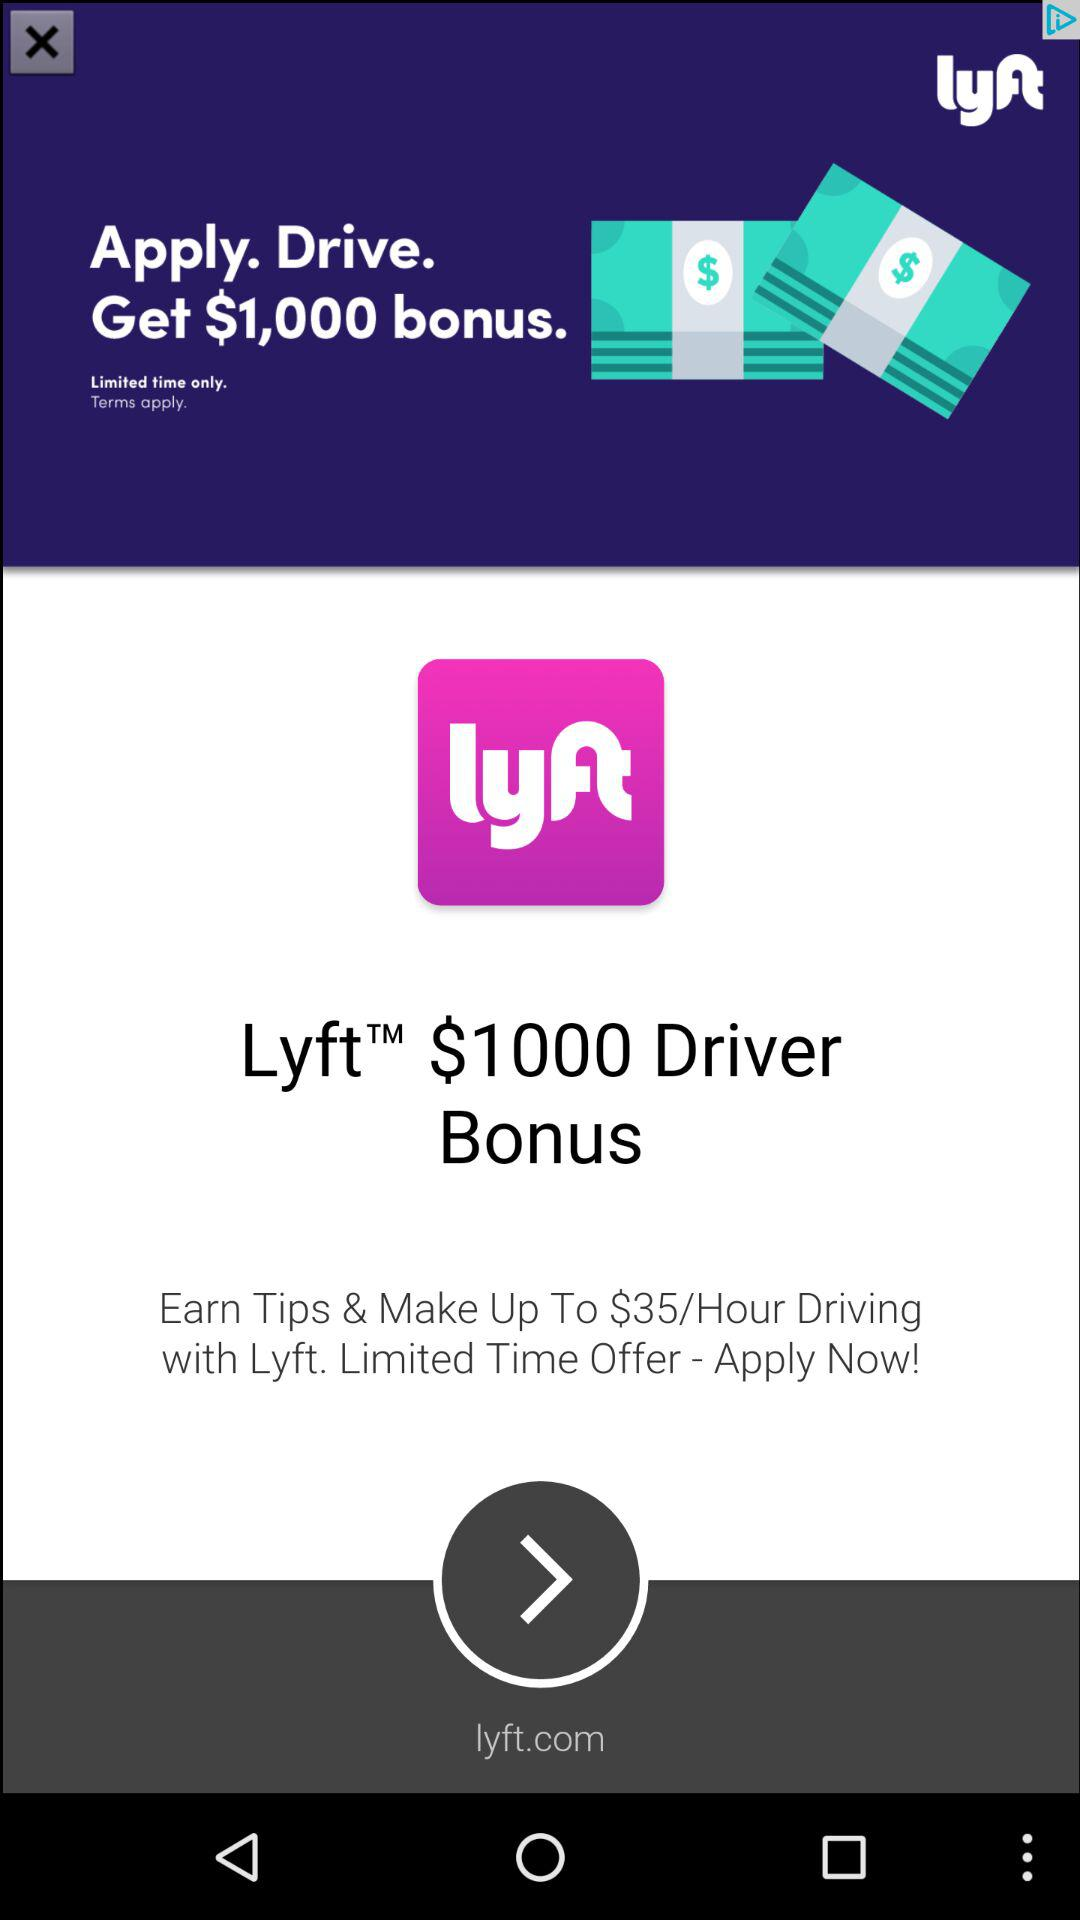How many dollars are offered as a bonus?
Answer the question using a single word or phrase. $1,000 